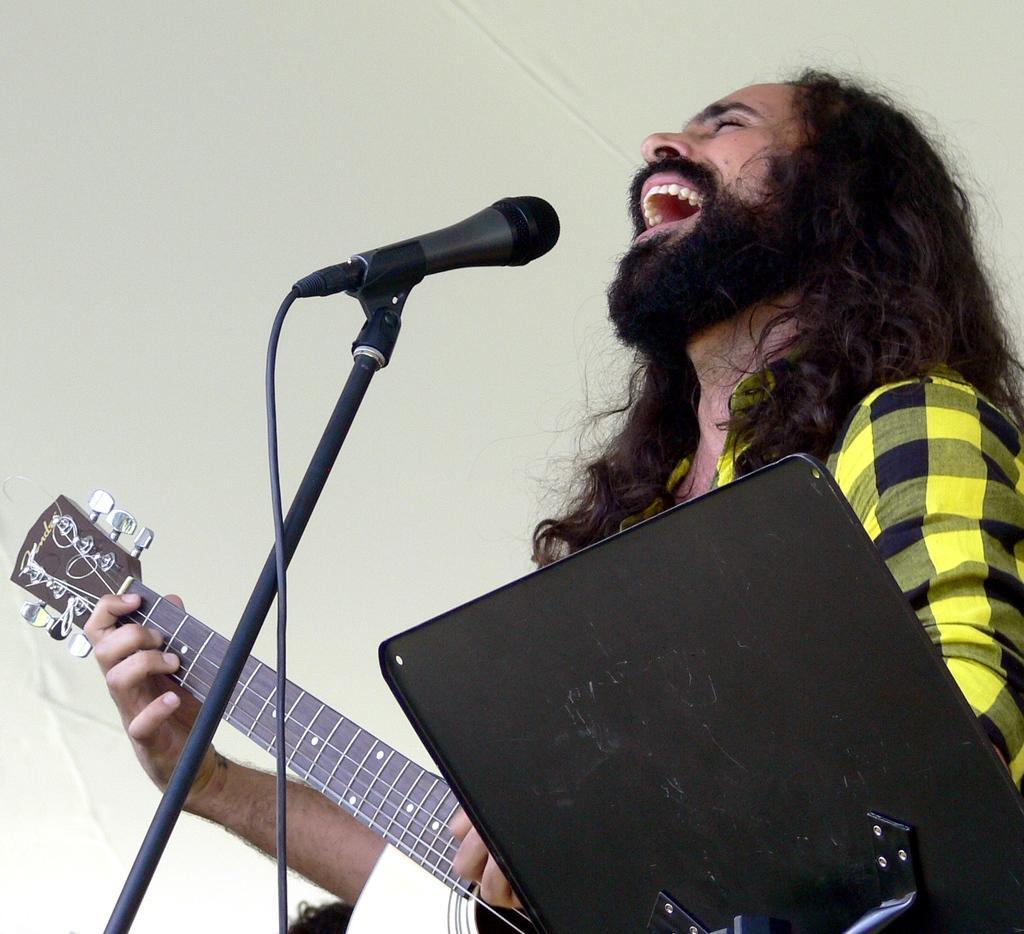In one or two sentences, can you explain what this image depicts? This man is playing a guitar and singing in-front of mic. This is mic holder. 